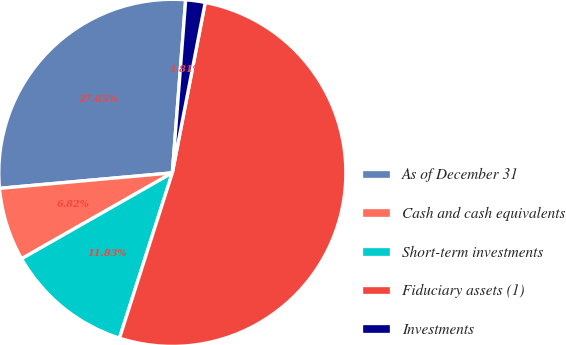Convert chart. <chart><loc_0><loc_0><loc_500><loc_500><pie_chart><fcel>As of December 31<fcel>Cash and cash equivalents<fcel>Short-term investments<fcel>Fiduciary assets (1)<fcel>Investments<nl><fcel>27.65%<fcel>6.82%<fcel>11.83%<fcel>51.89%<fcel>1.81%<nl></chart> 